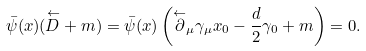Convert formula to latex. <formula><loc_0><loc_0><loc_500><loc_500>\bar { \psi } ( x ) ( \overset { \leftarrow } { \sl D } + m ) = \bar { \psi } ( x ) \left ( \overset { \leftarrow } { \partial } _ { \mu } \gamma _ { \mu } x _ { 0 } - \frac { d } { 2 } \gamma _ { 0 } + m \right ) = 0 .</formula> 